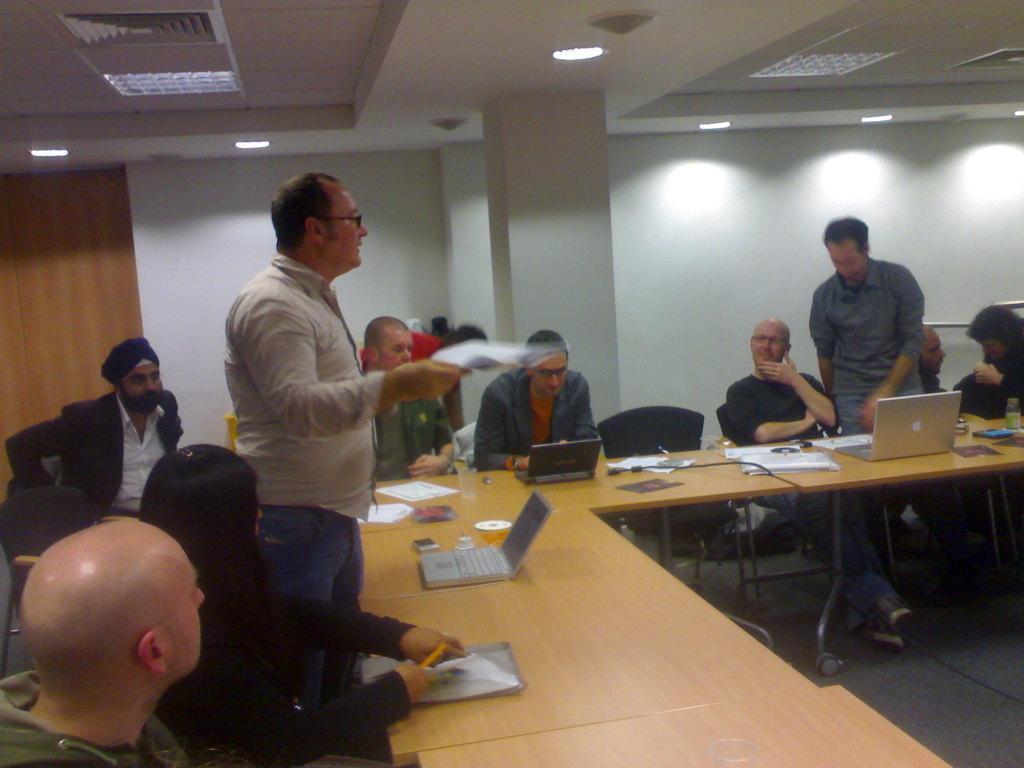Please provide a concise description of this image. In this image I can see group of people. Among them some of them are sitting and two people are standing. In front of them there is a laptop,glass,papers on the table. At the back there's a wall and lights. 